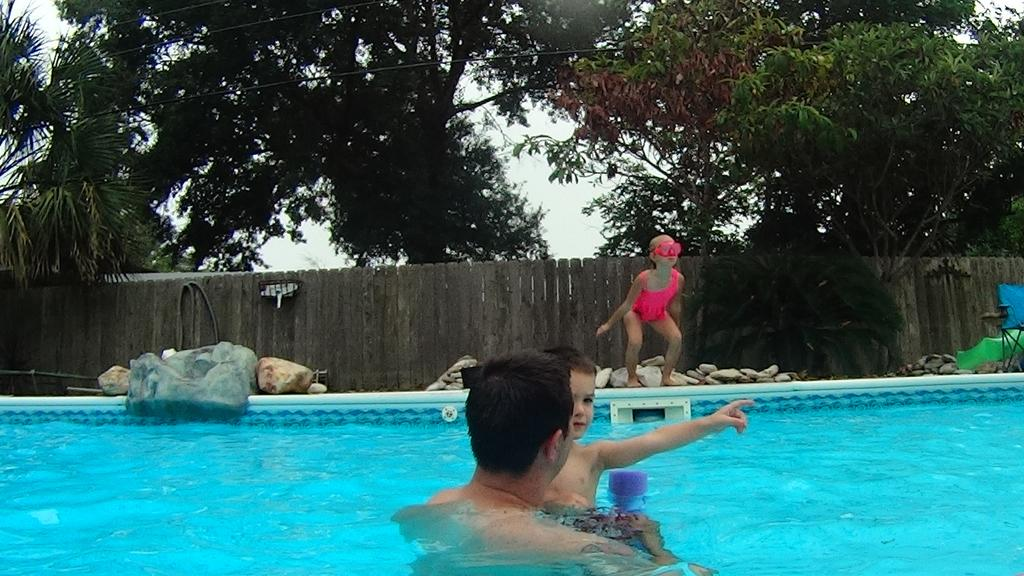What are the people in the image doing? There is a man and a boy swimming in the swimming pool, and a girl is standing in the center of the image. What can be seen in the background of the image? There is a fence, trees, and the sky visible in the background of the image. What is the temper of the owner of the swimming pool in the image? There is no indication of an owner in the image, and therefore no information about their temper can be determined. 